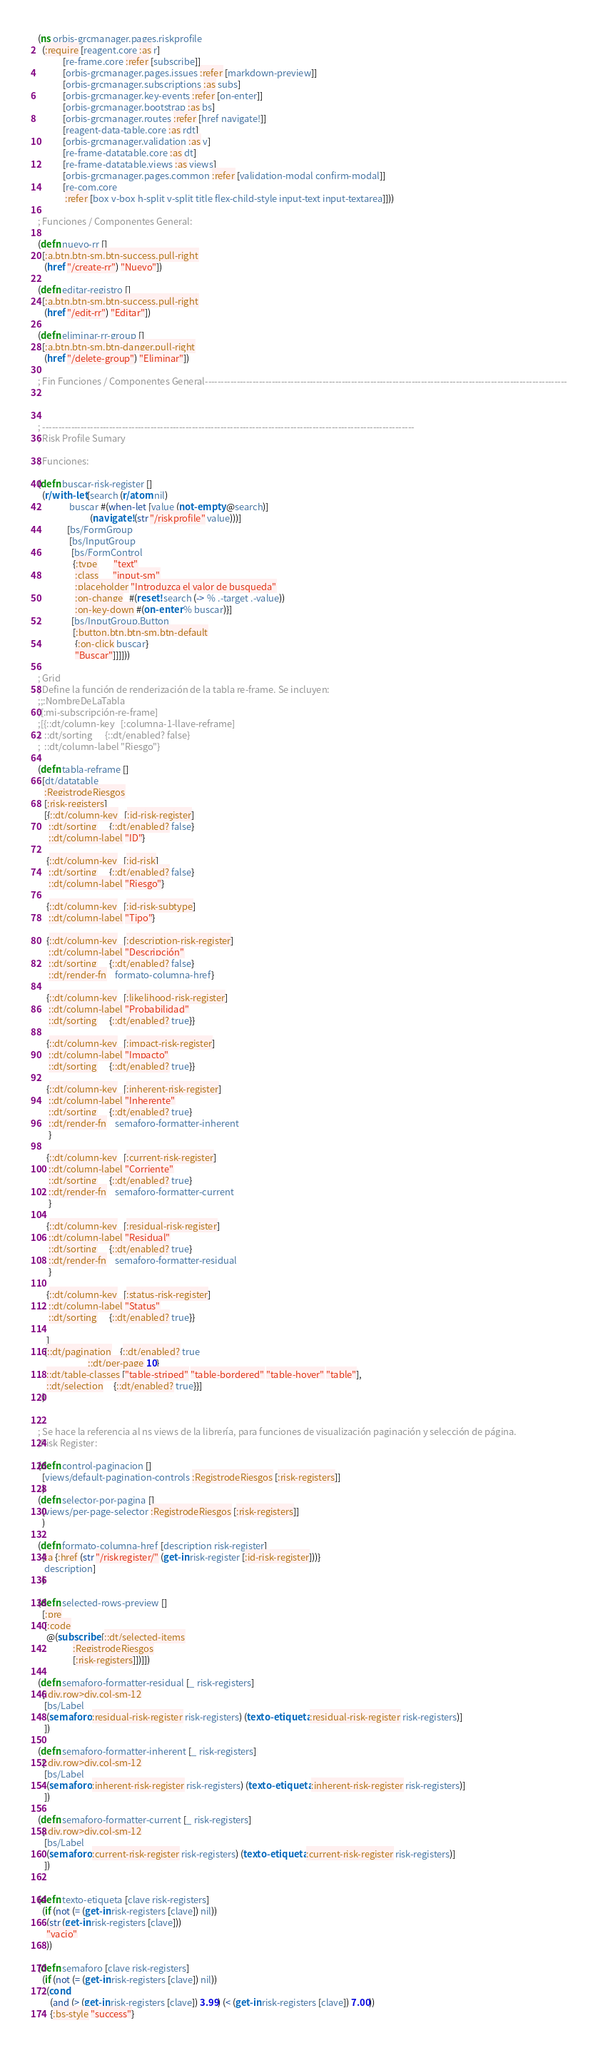<code> <loc_0><loc_0><loc_500><loc_500><_Clojure_>(ns orbis-grcmanager.pages.riskprofile
  (:require [reagent.core :as r]
            [re-frame.core :refer [subscribe]]
            [orbis-grcmanager.pages.issues :refer [markdown-preview]]
            [orbis-grcmanager.subscriptions :as subs]
            [orbis-grcmanager.key-events :refer [on-enter]]
            [orbis-grcmanager.bootstrap :as bs]
            [orbis-grcmanager.routes :refer [href navigate!]]
            [reagent-data-table.core :as rdt]
            [orbis-grcmanager.validation :as v]
            [re-frame-datatable.core :as dt]
            [re-frame-datatable.views :as views]
            [orbis-grcmanager.pages.common :refer [validation-modal confirm-modal]]
            [re-com.core
             :refer [box v-box h-split v-split title flex-child-style input-text input-textarea]]))

; Funciones / Componentes General:

(defn nuevo-rr []
  [:a.btn.btn-sm.btn-success.pull-right
   (href "/create-rr") "Nuevo"])

(defn editar-registro []
  [:a.btn.btn-sm.btn-success.pull-right
   (href "/edit-rr") "Editar"])

(defn eliminar-rr-group []
  [:a.btn.btn-sm.btn-danger.pull-right
   (href "/delete-group") "Eliminar"])

; Fin Funciones / Componentes General------------------------------------------------------------------------------------------------------------------



; ---------------------------------------------------------------------------------------------------------------------
; Risk Profile Sumary

; Funciones:

(defn buscar-risk-register []
  (r/with-let [search (r/atom nil)
               buscar #(when-let [value (not-empty @search)]
                         (navigate! (str "/riskprofile" value)))]
              [bs/FormGroup
               [bs/InputGroup
                [bs/FormControl
                 {:type        "text"
                  :class       "input-sm"
                  :placeholder "Introduzca el valor de busqueda"
                  :on-change   #(reset! search (-> % .-target .-value))
                  :on-key-down #(on-enter % buscar)}]
                [bs/InputGroup.Button
                 [:button.btn.btn-sm.btn-default
                  {:on-click buscar}
                  "Buscar"]]]]))

; Grid
; Define la función de renderización de la tabla re-frame. Se incluyen:
;;:NombreDeLaTabla
;[:mi-subscripción-re-frame]
;[{::dt/column-key   [:columna-1-llave-reframe]
;  ::dt/sorting      {::dt/enabled? false}
;  ::dt/column-label "Riesgo"}

(defn tabla-reframe []
  [dt/datatable
   :RegistrodeRiesgos
   [:risk-registers]
   [{::dt/column-key   [:id-risk-register]
     ::dt/sorting      {::dt/enabled? false}
     ::dt/column-label "ID"}

    {::dt/column-key   [:id-risk]
     ::dt/sorting      {::dt/enabled? false}
     ::dt/column-label "Riesgo"}

    {::dt/column-key   [:id-risk-subtype]
     ::dt/column-label "Tipo"}

    {::dt/column-key   [:description-risk-register]
     ::dt/column-label "Descripción"
     ::dt/sorting      {::dt/enabled? false}
     ::dt/render-fn    formato-columna-href}

    {::dt/column-key   [:likelihood-risk-register]
     ::dt/column-label "Probabilidad"
     ::dt/sorting      {::dt/enabled? true}}

    {::dt/column-key   [:impact-risk-register]
     ::dt/column-label "Impacto"
     ::dt/sorting      {::dt/enabled? true}}

    {::dt/column-key   [:inherent-risk-register]
     ::dt/column-label "Inherente"
     ::dt/sorting      {::dt/enabled? true}
     ::dt/render-fn    semaforo-formatter-inherent
     }

    {::dt/column-key   [:current-risk-register]
     ::dt/column-label "Corriente"
     ::dt/sorting      {::dt/enabled? true}
     ::dt/render-fn    semaforo-formatter-current
     }

    {::dt/column-key   [:residual-risk-register]
     ::dt/column-label "Residual"
     ::dt/sorting      {::dt/enabled? true}
     ::dt/render-fn    semaforo-formatter-residual
     }

    {::dt/column-key   [:status-risk-register]
     ::dt/column-label "Status"
     ::dt/sorting      {::dt/enabled? true}}

    ]
   {::dt/pagination    {::dt/enabled? true
                        ::dt/per-page 10}
    ::dt/table-classes ["table-striped" "table-bordered" "table-hover" "table"],
    ::dt/selection     {::dt/enabled? true}}]
  )


; Se hace la referencia al ns views de la librería, para funciones de visualización paginación y selección de página.
;Risk Register:

(defn control-paginacion []
  [views/default-pagination-controls :RegistrodeRiesgos [:risk-registers]]
  )
(defn selector-por-pagina []
  [views/per-page-selector :RegistrodeRiesgos [:risk-registers]]
  )

(defn formato-columna-href [description risk-register]
  [:a {:href (str "/riskregister/" (get-in risk-register [:id-risk-register]))}
   description]
  )

(defn selected-rows-preview []
  [:pre
   [:code
    @(subscribe [::dt/selected-items
                 :RegistrodeRiesgos
                 [:risk-registers]])]])

(defn semaforo-formatter-residual [_ risk-registers]
  [:div.row>div.col-sm-12
   [bs/Label
    (semaforo :residual-risk-register risk-registers) (texto-etiqueta :residual-risk-register risk-registers)]
   ])

(defn semaforo-formatter-inherent [_ risk-registers]
  [:div.row>div.col-sm-12
   [bs/Label
    (semaforo :inherent-risk-register risk-registers) (texto-etiqueta :inherent-risk-register risk-registers)]
   ])

(defn semaforo-formatter-current [_ risk-registers]
  [:div.row>div.col-sm-12
   [bs/Label
    (semaforo :current-risk-register risk-registers) (texto-etiqueta :current-risk-register risk-registers)]
   ])


(defn texto-etiqueta [clave risk-registers]
  (if (not (= (get-in risk-registers [clave]) nil))
    (str (get-in risk-registers [clave]))
    "vacio"
    ))

(defn semaforo [clave risk-registers]
  (if (not (= (get-in risk-registers [clave]) nil))
    (cond
      (and (> (get-in risk-registers [clave]) 3.99) (< (get-in risk-registers [clave]) 7.00))
      {:bs-style "success"}</code> 